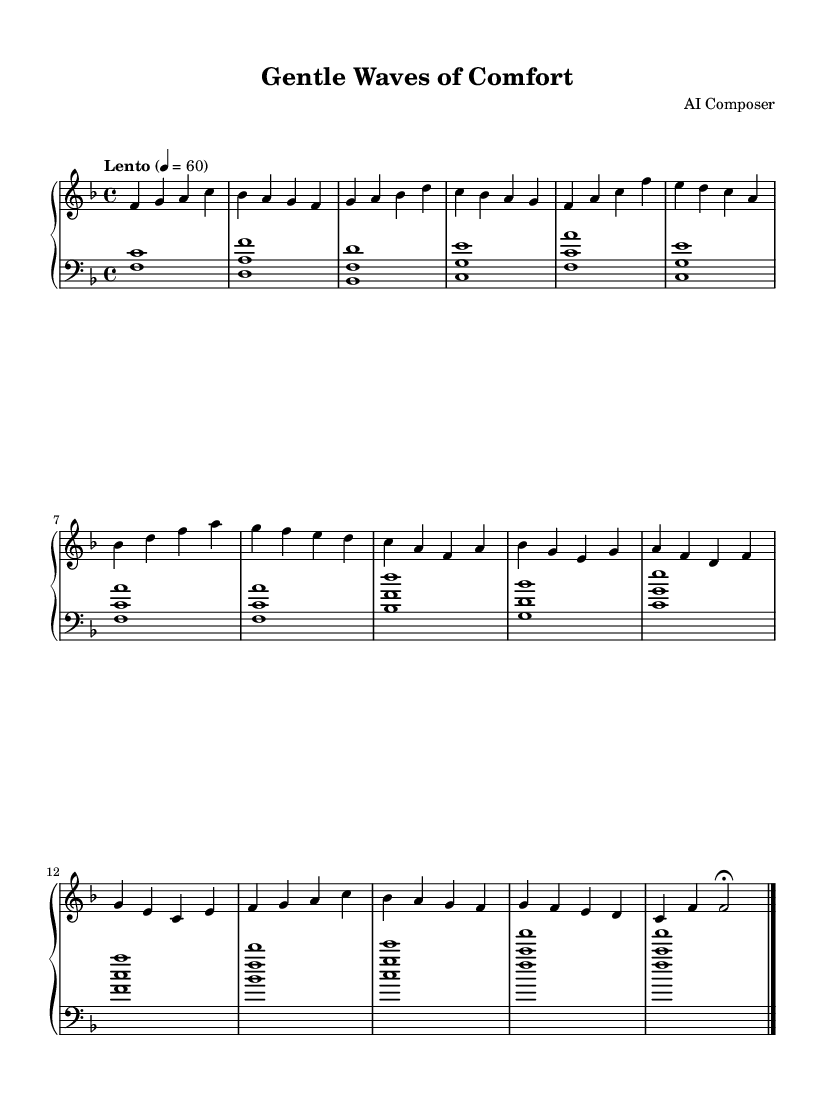What is the key signature of this music? The key signature is F major, which is indicated by one flat (B flat).
Answer: F major What is the time signature of this music? The time signature is indicated at the beginning and is 4/4, meaning there are four beats in each measure.
Answer: 4/4 What is the tempo marking for this piece? The tempo marking at the beginning is "Lento," which means slow. Additionally, the metronome marking is set at 60 beats per minute.
Answer: Lento How many measures are there in this piece? By counting the measures from the beginning to the end of the score, there are a total of 14 measures.
Answer: 14 What is the range of the left hand in this composition? The left hand starts on F below middle C and plays up to A in the fourth octave, covering a range of a tenth.
Answer: F to A Which type of chords are predominantly used in the left hand? The left hand primarily uses triadic chords formed using the root position and first inversion.
Answer: Triadic chords What mood does this piece aim to convey? The music aims to evoke a soothing and comfortable mood suitable for relaxation and pain management, indicated by its slow tempo and gentle melodic patterns.
Answer: Soothing 